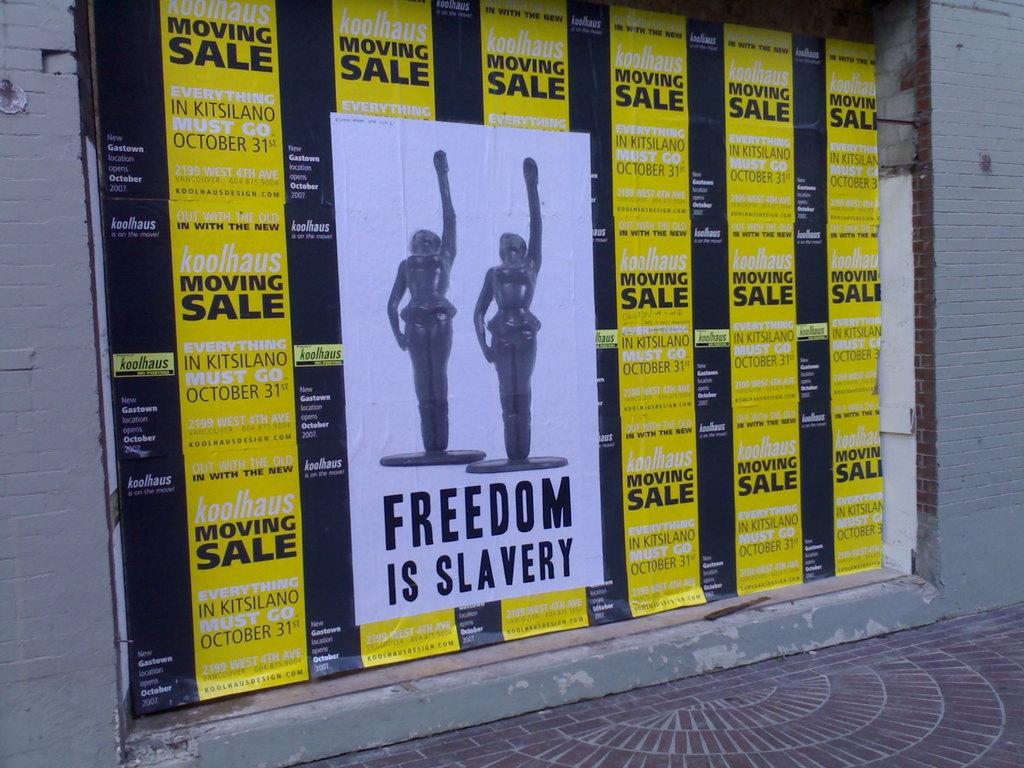<image>
Create a compact narrative representing the image presented. Yellow banners side by side with the writing Moving Sale and in the center of the banners a large poster with two statues displayed titled Freedom is slavery 